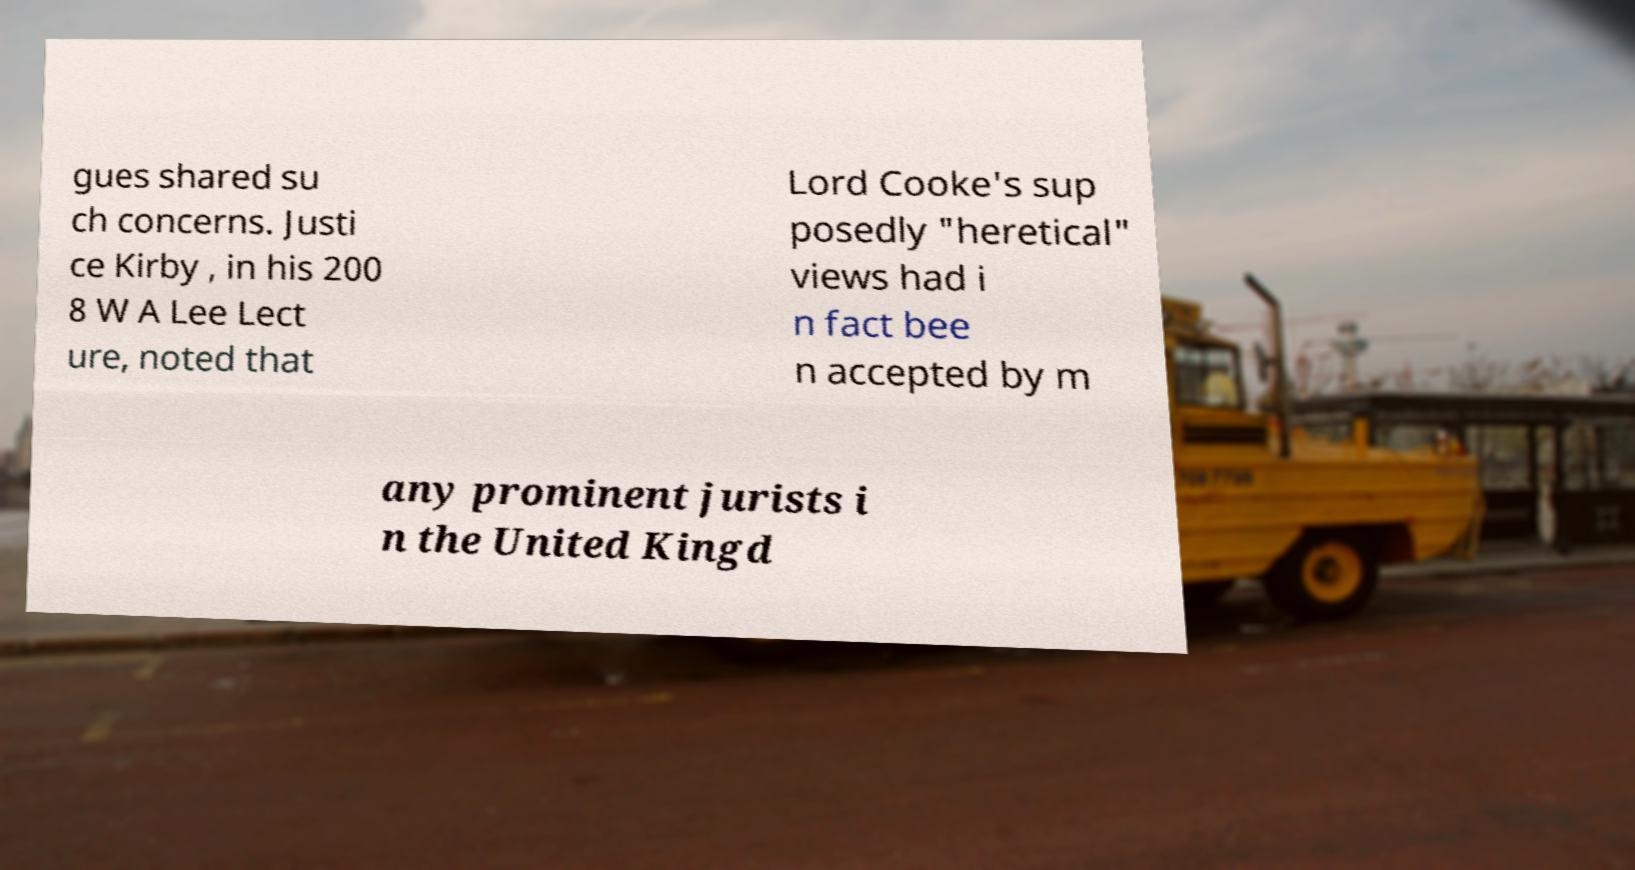I need the written content from this picture converted into text. Can you do that? gues shared su ch concerns. Justi ce Kirby , in his 200 8 W A Lee Lect ure, noted that Lord Cooke's sup posedly "heretical" views had i n fact bee n accepted by m any prominent jurists i n the United Kingd 